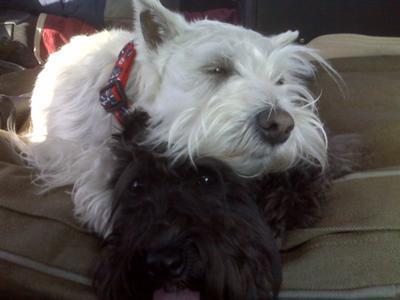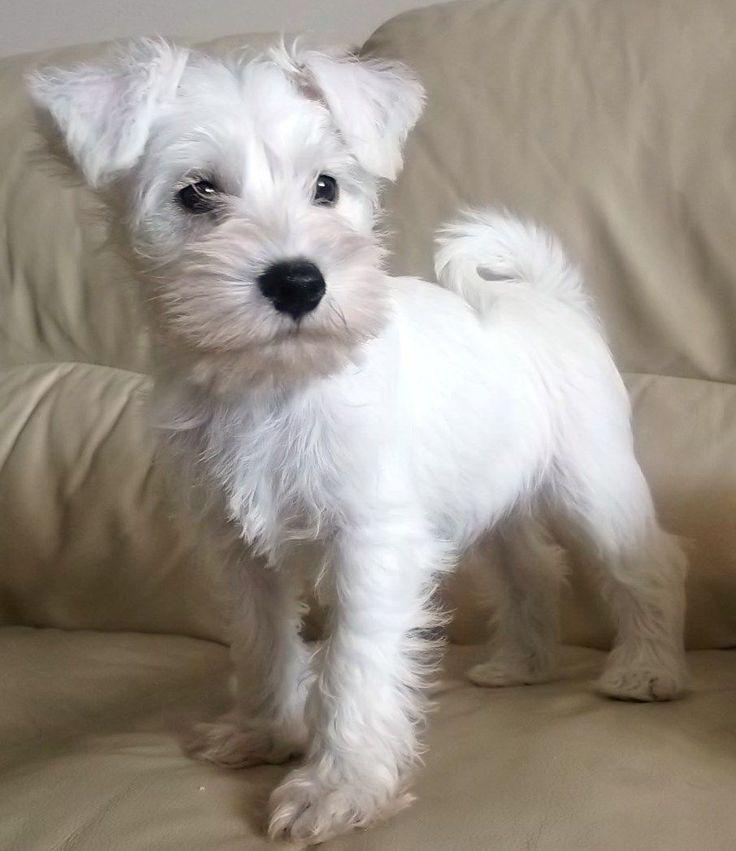The first image is the image on the left, the second image is the image on the right. Given the left and right images, does the statement "a single dog is sitting on a tile floor" hold true? Answer yes or no. No. The first image is the image on the left, the second image is the image on the right. Examine the images to the left and right. Is the description "One puppy is sitting on tile flooring." accurate? Answer yes or no. No. 